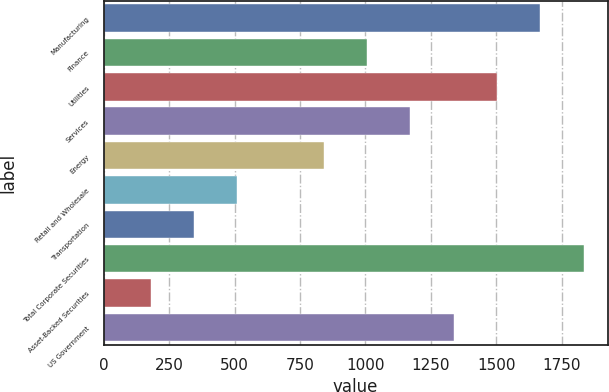Convert chart. <chart><loc_0><loc_0><loc_500><loc_500><bar_chart><fcel>Manufacturing<fcel>Finance<fcel>Utilities<fcel>Services<fcel>Energy<fcel>Retail and Wholesale<fcel>Transportation<fcel>Total Corporate Securities<fcel>Asset-Backed Securities<fcel>US Government<nl><fcel>1667<fcel>1005.8<fcel>1501.7<fcel>1171.1<fcel>840.5<fcel>509.9<fcel>344.6<fcel>1832.3<fcel>179.3<fcel>1336.4<nl></chart> 